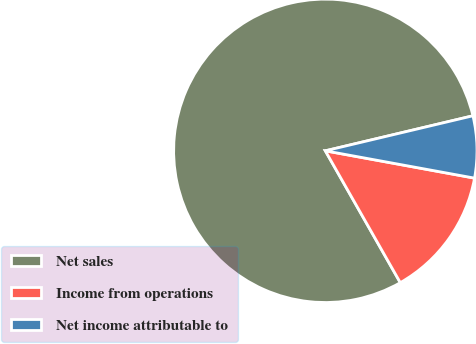Convert chart to OTSL. <chart><loc_0><loc_0><loc_500><loc_500><pie_chart><fcel>Net sales<fcel>Income from operations<fcel>Net income attributable to<nl><fcel>79.52%<fcel>13.89%<fcel>6.59%<nl></chart> 